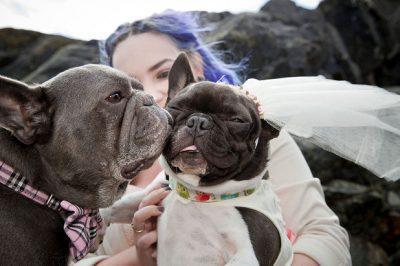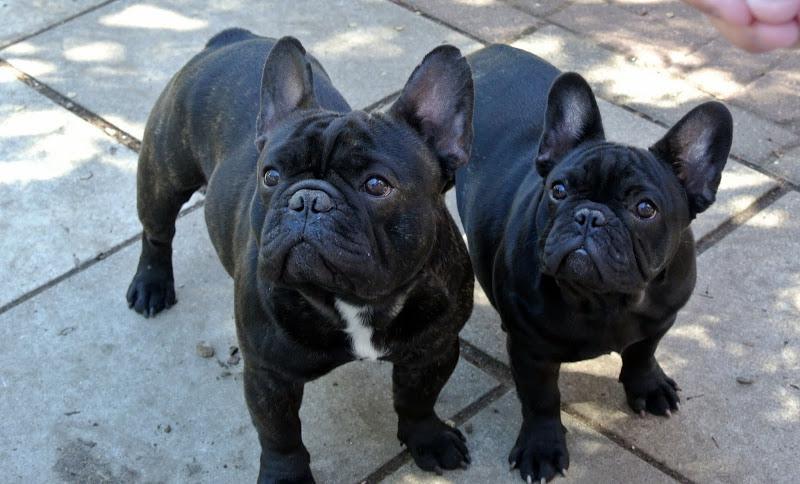The first image is the image on the left, the second image is the image on the right. For the images shown, is this caption "There are two french bull dogs laying on a bed." true? Answer yes or no. No. The first image is the image on the left, the second image is the image on the right. Analyze the images presented: Is the assertion "An image shows two tan-colored dogs lounging on a cushioned item." valid? Answer yes or no. No. 